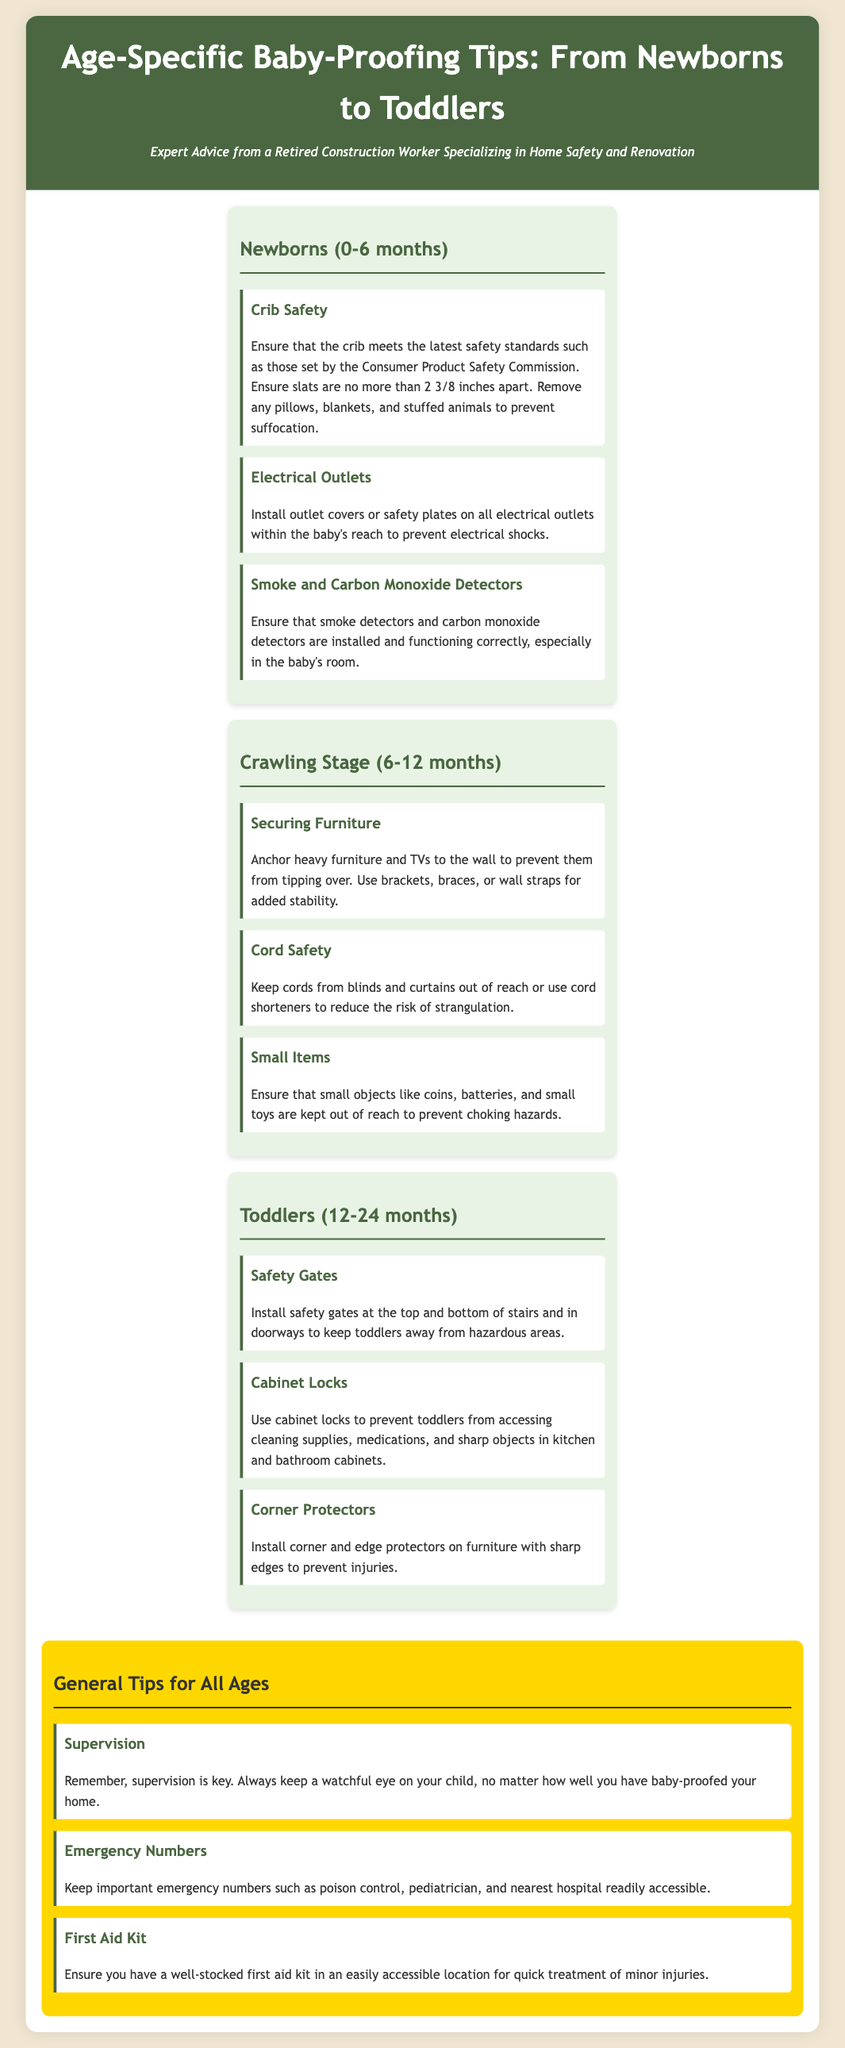what is the age range for newborns? The age range for newborns is specified in the document as 0-6 months.
Answer: 0-6 months what should be ensured about crib slats? The document states that crib slats should be no more than 2 3/8 inches apart.
Answer: 2 3/8 inches what is a recommended safety measure for cords? It is recommended to keep cords from blinds and curtains out of reach or use cord shorteners.
Answer: use cord shorteners what should be installed at the top and bottom of stairs for toddlers? The document suggests installing safety gates at the top and bottom of stairs for toddlers.
Answer: safety gates how many specific tips are provided for the crawling stage? The crawling stage section comprises three specific tips.
Answer: three what is a key general tip mentioned for all ages? The key general tip mentioned for all ages is that supervision is essential.
Answer: supervision what is the purpose of installing cabinet locks? Cabinet locks are used to prevent toddlers from accessing cleaning supplies, medications, and sharp objects.
Answer: prevent access to hazards how should furniture be secured according to the document? The document advises to anchor heavy furniture and TVs to the wall for safety.
Answer: anchor to the wall what is the focus of this document? The document focuses on age-specific baby-proofing tips from newborns to toddlers.
Answer: baby-proofing tips 